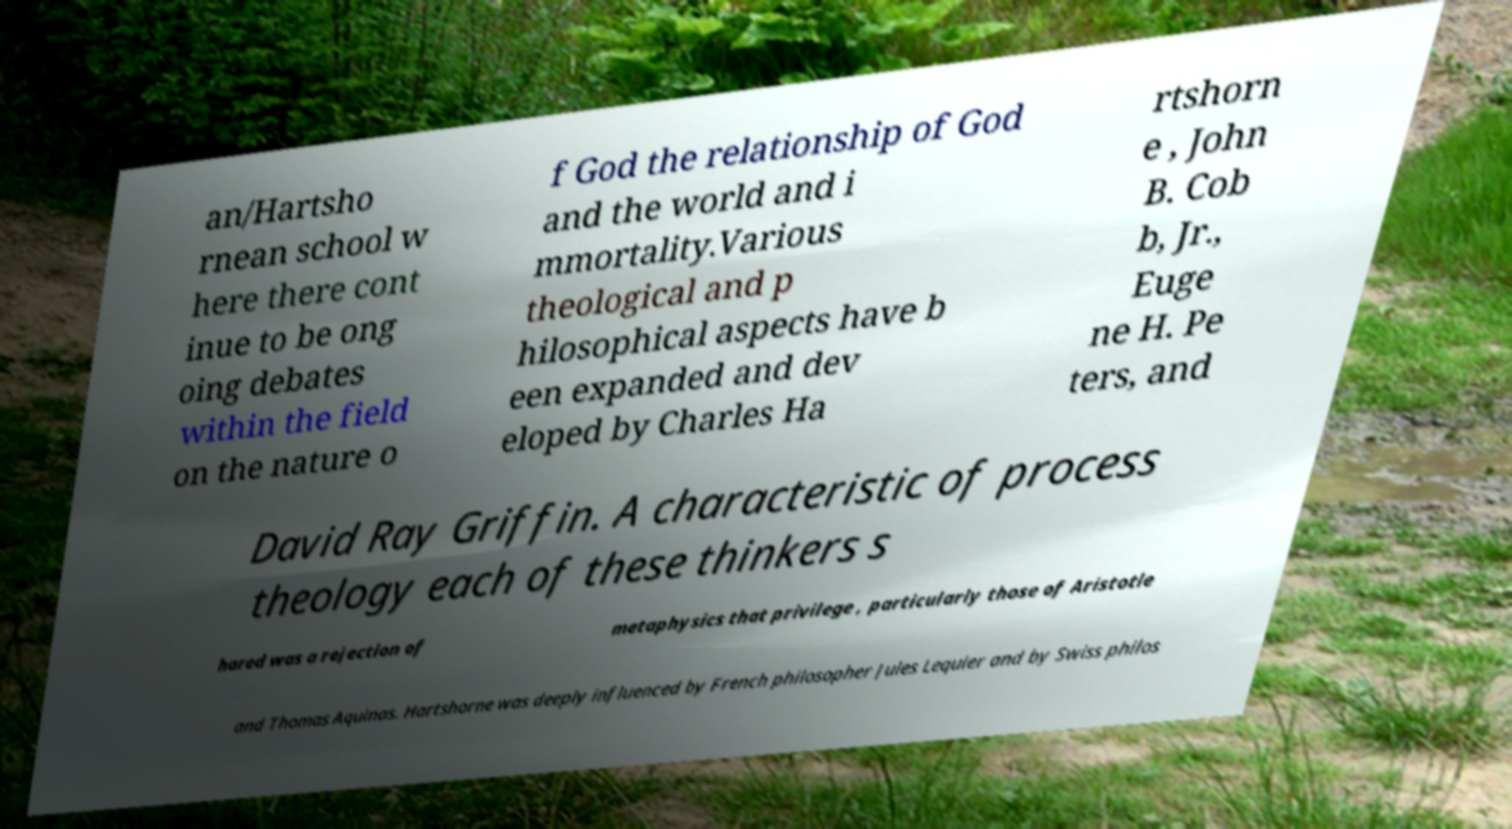There's text embedded in this image that I need extracted. Can you transcribe it verbatim? an/Hartsho rnean school w here there cont inue to be ong oing debates within the field on the nature o f God the relationship of God and the world and i mmortality.Various theological and p hilosophical aspects have b een expanded and dev eloped by Charles Ha rtshorn e , John B. Cob b, Jr., Euge ne H. Pe ters, and David Ray Griffin. A characteristic of process theology each of these thinkers s hared was a rejection of metaphysics that privilege , particularly those of Aristotle and Thomas Aquinas. Hartshorne was deeply influenced by French philosopher Jules Lequier and by Swiss philos 